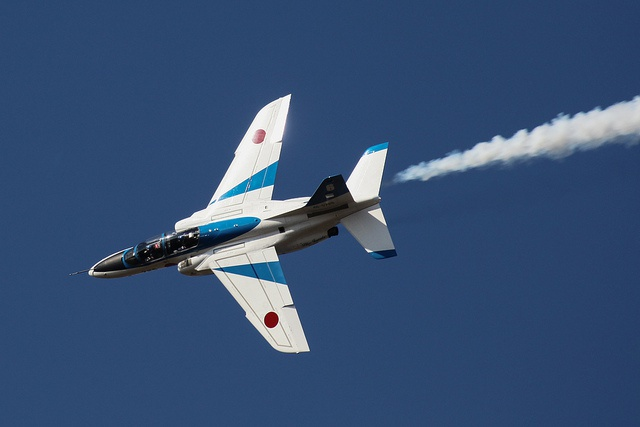Describe the objects in this image and their specific colors. I can see a airplane in darkblue, lightgray, black, gray, and teal tones in this image. 